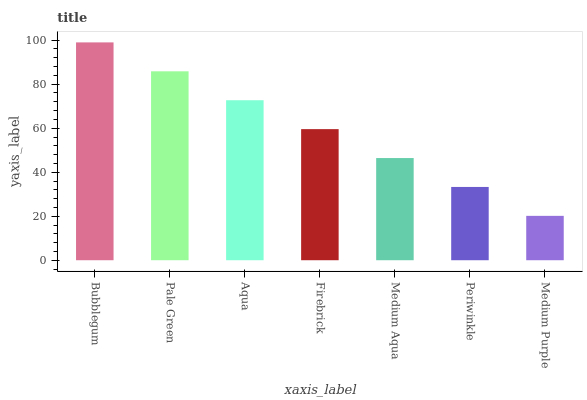Is Pale Green the minimum?
Answer yes or no. No. Is Pale Green the maximum?
Answer yes or no. No. Is Bubblegum greater than Pale Green?
Answer yes or no. Yes. Is Pale Green less than Bubblegum?
Answer yes or no. Yes. Is Pale Green greater than Bubblegum?
Answer yes or no. No. Is Bubblegum less than Pale Green?
Answer yes or no. No. Is Firebrick the high median?
Answer yes or no. Yes. Is Firebrick the low median?
Answer yes or no. Yes. Is Pale Green the high median?
Answer yes or no. No. Is Periwinkle the low median?
Answer yes or no. No. 